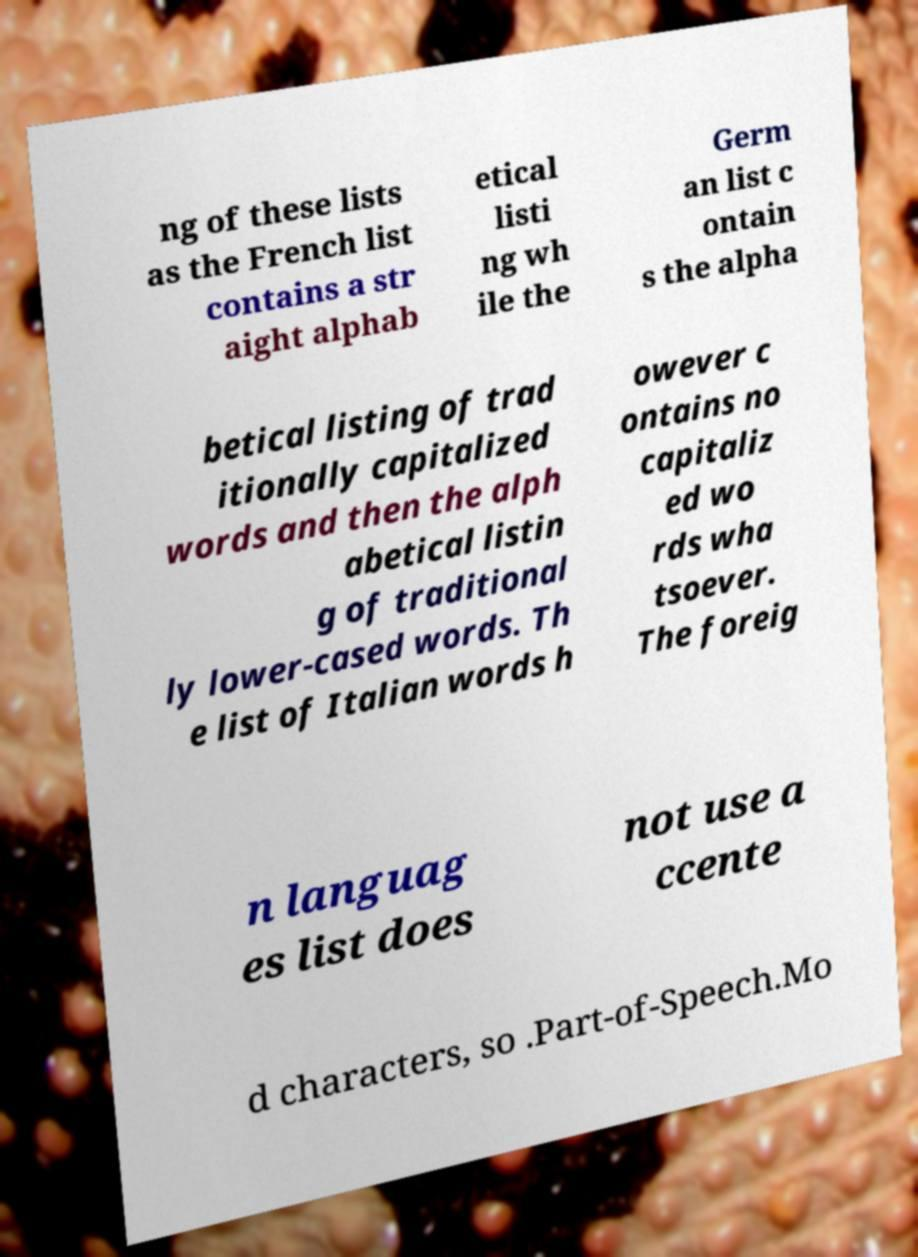For documentation purposes, I need the text within this image transcribed. Could you provide that? ng of these lists as the French list contains a str aight alphab etical listi ng wh ile the Germ an list c ontain s the alpha betical listing of trad itionally capitalized words and then the alph abetical listin g of traditional ly lower-cased words. Th e list of Italian words h owever c ontains no capitaliz ed wo rds wha tsoever. The foreig n languag es list does not use a ccente d characters, so .Part-of-Speech.Mo 